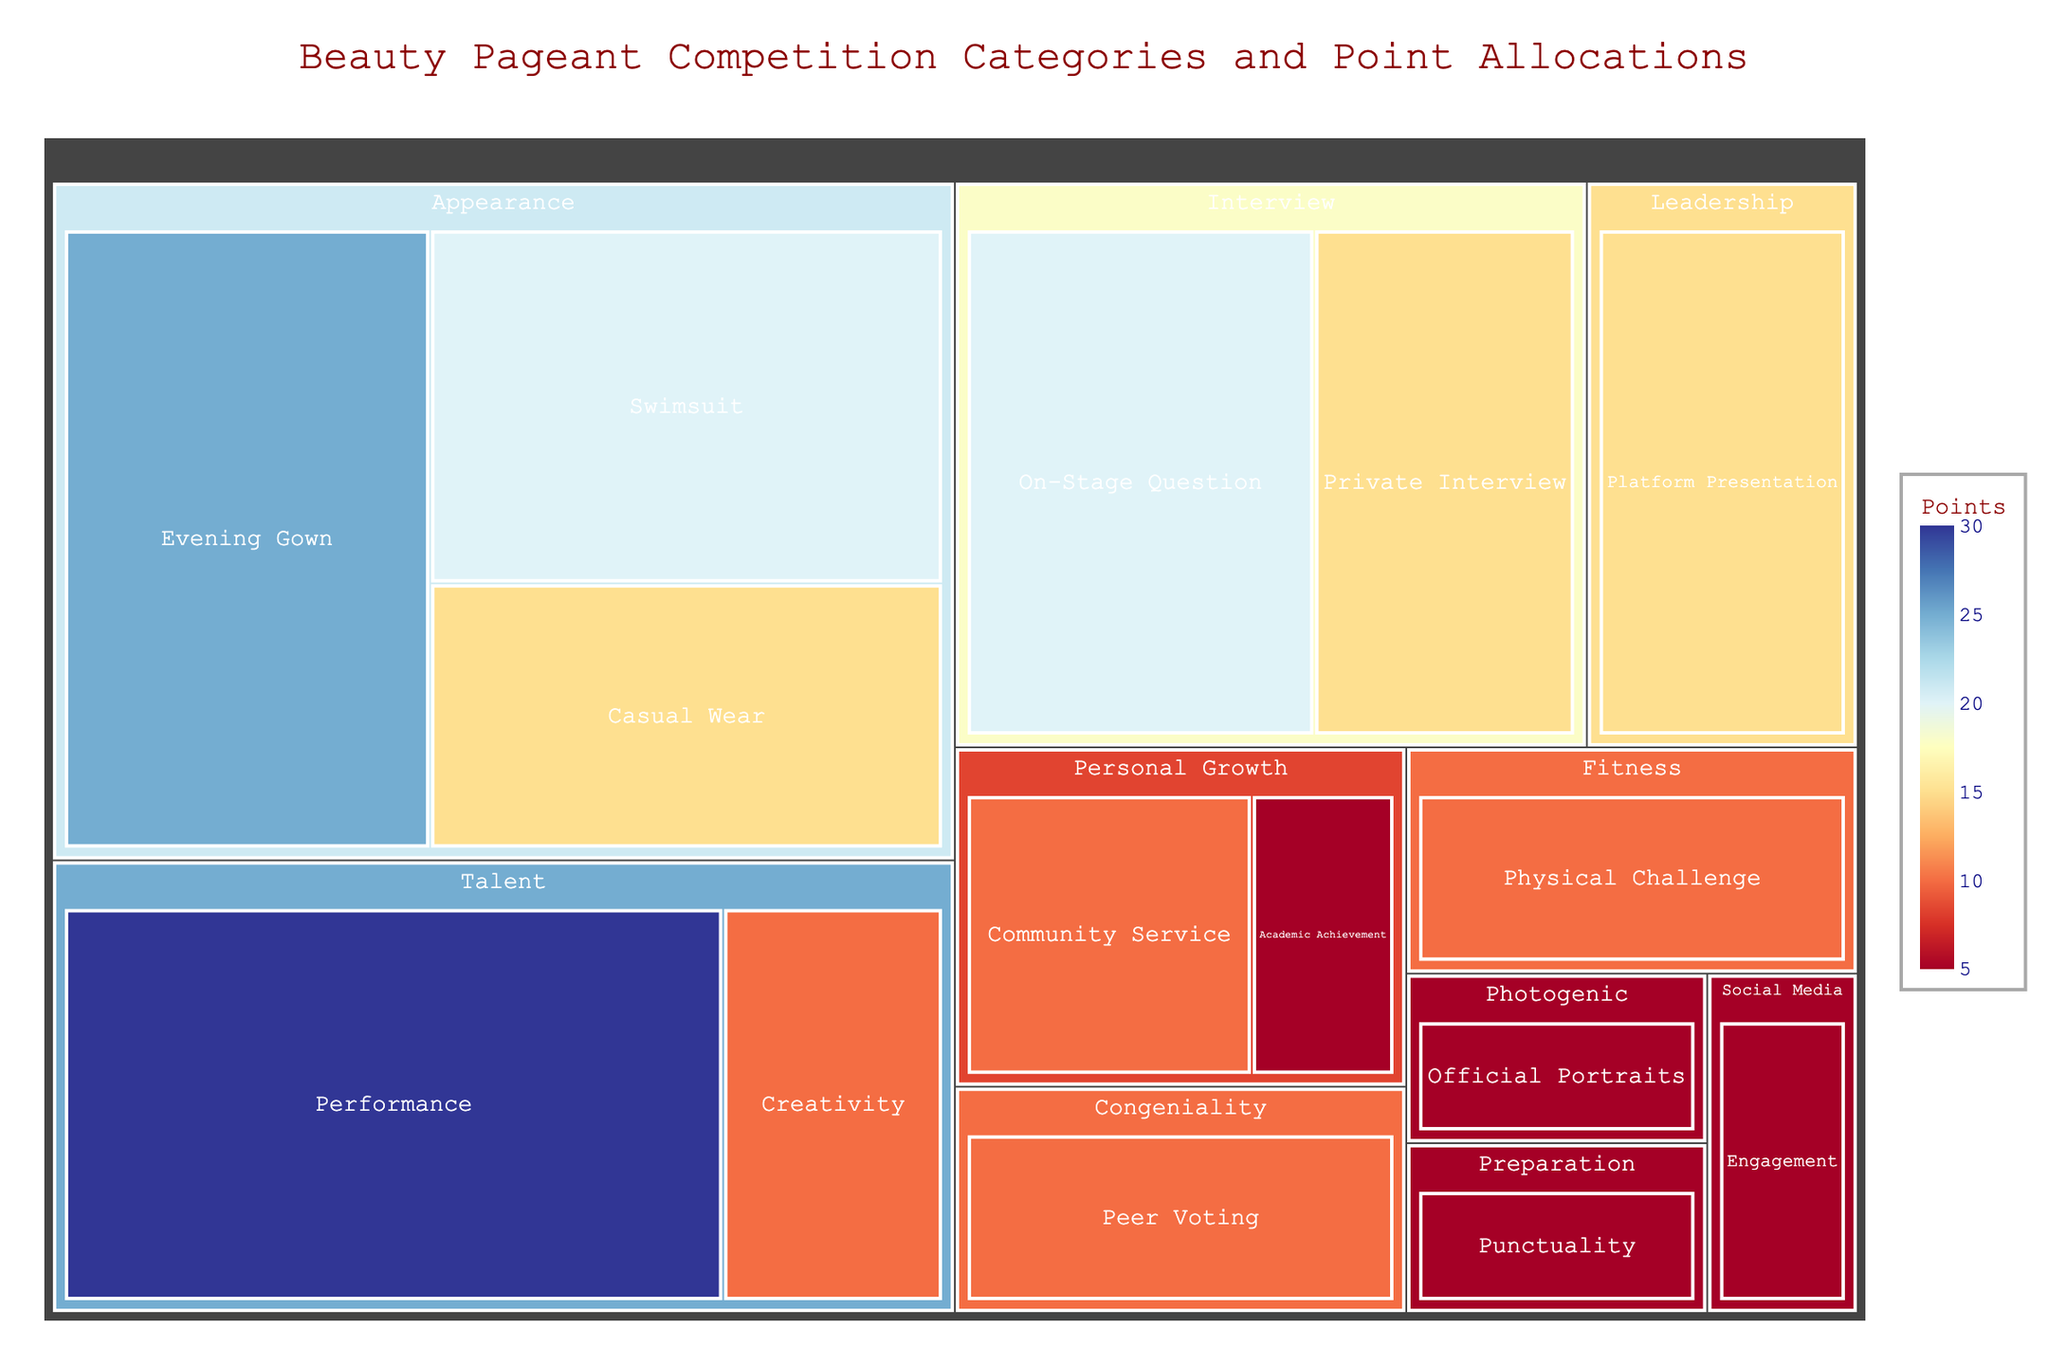Which category has the highest point allocation? The treemap shows different categories with their point allocations. The "Talent" category, specifically the "Performance" subcategory, has the highest point allocation, which is 30 points.
Answer: Talent What is the total number of points allocated for the "Appearance" category? The "Appearance" category includes "Evening Gown" (25 points), "Swimsuit" (20 points), and "Casual Wear" (15 points). Adding these gives 25 + 20 + 15 = 60 points in total.
Answer: 60 How does the point allocation for "On-Stage Question" compare to "Private Interview"? Both subcategories belong to the "Interview" category. "On-Stage Question" has 20 points and "Private Interview" has 15 points. The "On-Stage Question" has 5 more points than "Private Interview".
Answer: "On-Stage Question" has 5 more points Which subcategory under "Personal Growth" has a higher point allocation? The subcategories under "Personal Growth" are "Community Service" and "Academic Achievement". "Community Service" is allocated 10 points, whereas "Academic Achievement" is allocated 5 points. Therefore, "Community Service" has a higher point allocation.
Answer: Community Service What is the combined point allocation for the "Fitness" and "Leadership" categories? The "Fitness" category has "Physical Challenge" (10 points), and the "Leadership" category has "Platform Presentation" (15 points). Adding these gives 10 + 15 = 25 points in total.
Answer: 25 Identify a category with the smallest point allocation and state its points. The categories with the smallest point allocation are "Photogenic" (5 points), "Social Media" (5 points), "Preparation" (5 points), and "Personal Growth" under "Academic Achievement" (5 points).
Answer: Various categories have 5 points each What is the primary color for the subcategory with the highest point allocation? "Performance" under the "Talent" category has the highest point allocation of 30 points. The primary color representing the highest points in the treemap is generally darker in a continuous color scale, which is likely dark blue or similar.
Answer: Dark blue Calculate the average point allocation across all subcategories. There are 15 subcategories with respective points: 25, 20, 15, 30, 10, 20, 15, 10, 5, 10, 5, 5, 10, 15, 5. Summing these gives 200 points. The average is 200 / 15 = 13.33 points.
Answer: 13.33 Which subcategory has equal points to "On-Stage Question"? "On-Stage Question" has 20 points. The other subcategory with the same points is "Swimsuit" under the "Appearance" category, which also has 20 points.
Answer: Swimsuit What is the total point allocation for subcategories under "Interview"? The subcategories "On-Stage Question" (20 points) and "Private Interview" (15 points) belong to the "Interview" category. The total is 20 + 15 = 35 points.
Answer: 35 